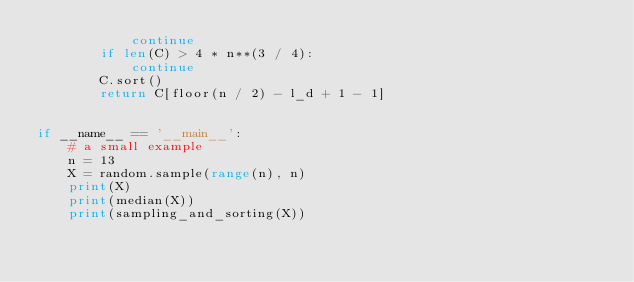Convert code to text. <code><loc_0><loc_0><loc_500><loc_500><_Python_>            continue
        if len(C) > 4 * n**(3 / 4):
            continue
        C.sort()
        return C[floor(n / 2) - l_d + 1 - 1]


if __name__ == '__main__':
    # a small example
    n = 13
    X = random.sample(range(n), n)
    print(X)
    print(median(X))
    print(sampling_and_sorting(X))
</code> 